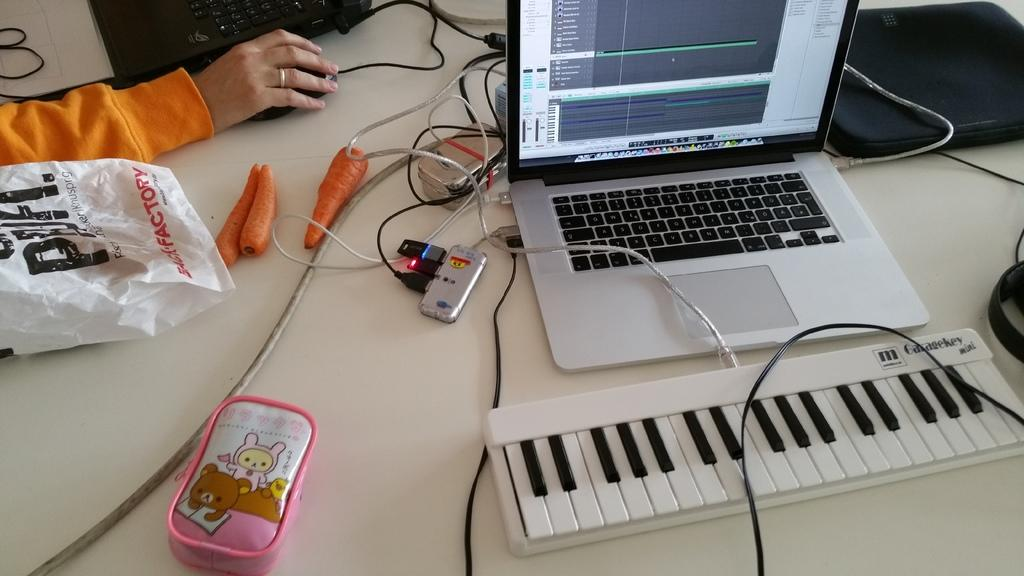What is covering the table in the image? There is a plastic cover on the table. What type of food can be seen on the table? There are carrots on the table. What electronic components are present on the table? There are cables and a connector on the table. What is the woman holding in her hand? The woman is holding a mouse in her hand. How many laptops are on the table? There are two laptops on the table. What additional item can be seen on the table? There is a piano board on the table. What type of fruit is being used as a decoration on the piano board? There is no fruit, including bananas, present on the piano board in the image. What type of straw is being used to hold the cables together? There is no straw present in the image; the cables are not held together by any visible object. 